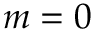<formula> <loc_0><loc_0><loc_500><loc_500>m = 0</formula> 